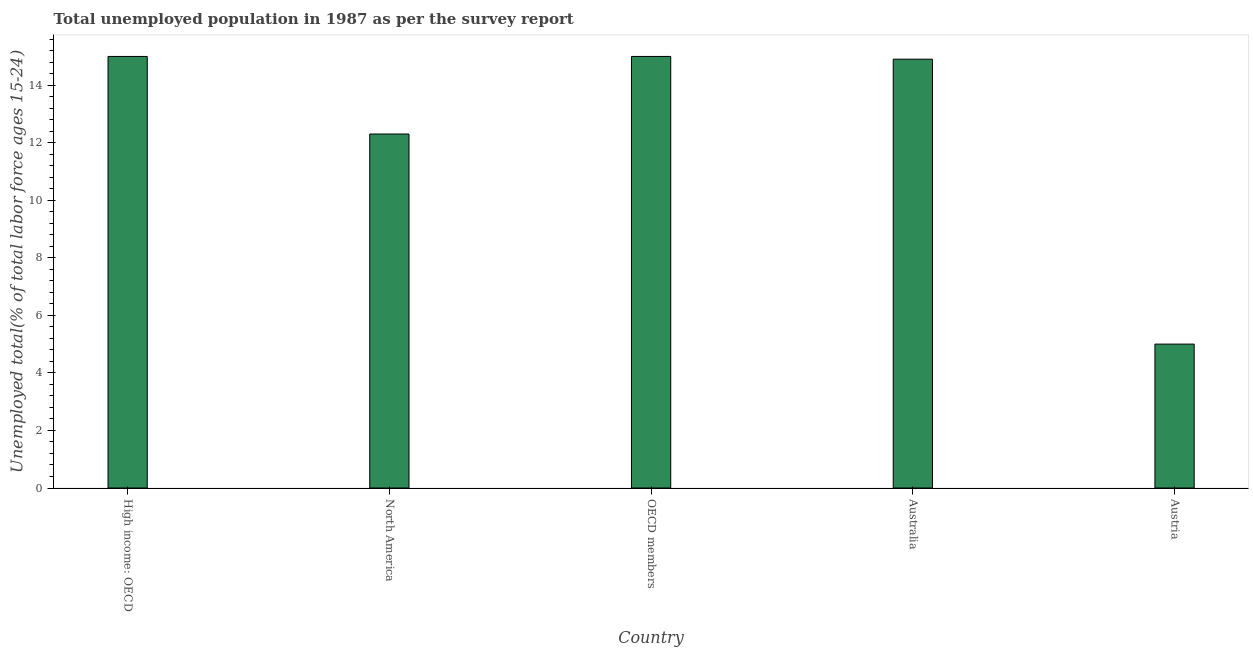Does the graph contain any zero values?
Provide a succinct answer. No. What is the title of the graph?
Offer a very short reply. Total unemployed population in 1987 as per the survey report. What is the label or title of the X-axis?
Your answer should be very brief. Country. What is the label or title of the Y-axis?
Ensure brevity in your answer.  Unemployed total(% of total labor force ages 15-24). What is the unemployed youth in Australia?
Keep it short and to the point. 14.9. Across all countries, what is the maximum unemployed youth?
Make the answer very short. 15. In which country was the unemployed youth maximum?
Give a very brief answer. High income: OECD. What is the sum of the unemployed youth?
Offer a terse response. 62.19. What is the difference between the unemployed youth in Australia and High income: OECD?
Your answer should be very brief. -0.1. What is the average unemployed youth per country?
Your answer should be compact. 12.44. What is the median unemployed youth?
Your answer should be very brief. 14.9. In how many countries, is the unemployed youth greater than 8.4 %?
Offer a very short reply. 4. What is the ratio of the unemployed youth in North America to that in OECD members?
Give a very brief answer. 0.82. What is the difference between the highest and the second highest unemployed youth?
Keep it short and to the point. 0. Is the sum of the unemployed youth in High income: OECD and North America greater than the maximum unemployed youth across all countries?
Offer a terse response. Yes. In how many countries, is the unemployed youth greater than the average unemployed youth taken over all countries?
Your response must be concise. 3. How many bars are there?
Your answer should be compact. 5. Are all the bars in the graph horizontal?
Your response must be concise. No. How many countries are there in the graph?
Provide a succinct answer. 5. What is the Unemployed total(% of total labor force ages 15-24) in High income: OECD?
Offer a very short reply. 15. What is the Unemployed total(% of total labor force ages 15-24) of North America?
Ensure brevity in your answer.  12.3. What is the Unemployed total(% of total labor force ages 15-24) of OECD members?
Ensure brevity in your answer.  15. What is the Unemployed total(% of total labor force ages 15-24) in Australia?
Provide a short and direct response. 14.9. What is the Unemployed total(% of total labor force ages 15-24) in Austria?
Your answer should be compact. 5. What is the difference between the Unemployed total(% of total labor force ages 15-24) in High income: OECD and North America?
Provide a succinct answer. 2.69. What is the difference between the Unemployed total(% of total labor force ages 15-24) in High income: OECD and Australia?
Ensure brevity in your answer.  0.1. What is the difference between the Unemployed total(% of total labor force ages 15-24) in High income: OECD and Austria?
Make the answer very short. 10. What is the difference between the Unemployed total(% of total labor force ages 15-24) in North America and OECD members?
Offer a terse response. -2.69. What is the difference between the Unemployed total(% of total labor force ages 15-24) in North America and Australia?
Your answer should be very brief. -2.6. What is the difference between the Unemployed total(% of total labor force ages 15-24) in North America and Austria?
Give a very brief answer. 7.3. What is the difference between the Unemployed total(% of total labor force ages 15-24) in OECD members and Australia?
Make the answer very short. 0.1. What is the difference between the Unemployed total(% of total labor force ages 15-24) in OECD members and Austria?
Make the answer very short. 10. What is the ratio of the Unemployed total(% of total labor force ages 15-24) in High income: OECD to that in North America?
Offer a very short reply. 1.22. What is the ratio of the Unemployed total(% of total labor force ages 15-24) in High income: OECD to that in Australia?
Provide a short and direct response. 1.01. What is the ratio of the Unemployed total(% of total labor force ages 15-24) in High income: OECD to that in Austria?
Make the answer very short. 3. What is the ratio of the Unemployed total(% of total labor force ages 15-24) in North America to that in OECD members?
Your response must be concise. 0.82. What is the ratio of the Unemployed total(% of total labor force ages 15-24) in North America to that in Australia?
Your response must be concise. 0.83. What is the ratio of the Unemployed total(% of total labor force ages 15-24) in North America to that in Austria?
Offer a very short reply. 2.46. What is the ratio of the Unemployed total(% of total labor force ages 15-24) in OECD members to that in Austria?
Provide a short and direct response. 3. What is the ratio of the Unemployed total(% of total labor force ages 15-24) in Australia to that in Austria?
Offer a very short reply. 2.98. 